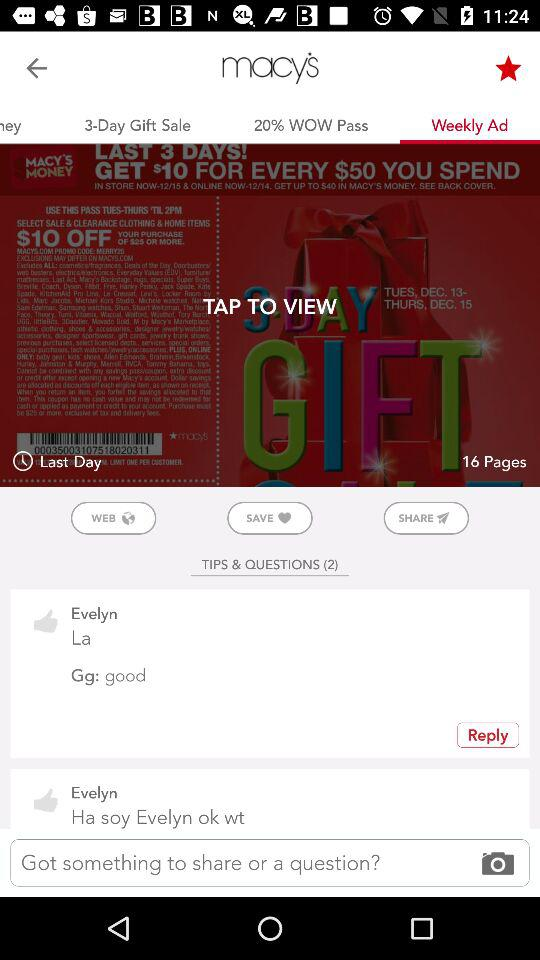How many thumbs up reactions does Evelyn have on this post?
Answer the question using a single word or phrase. 2 